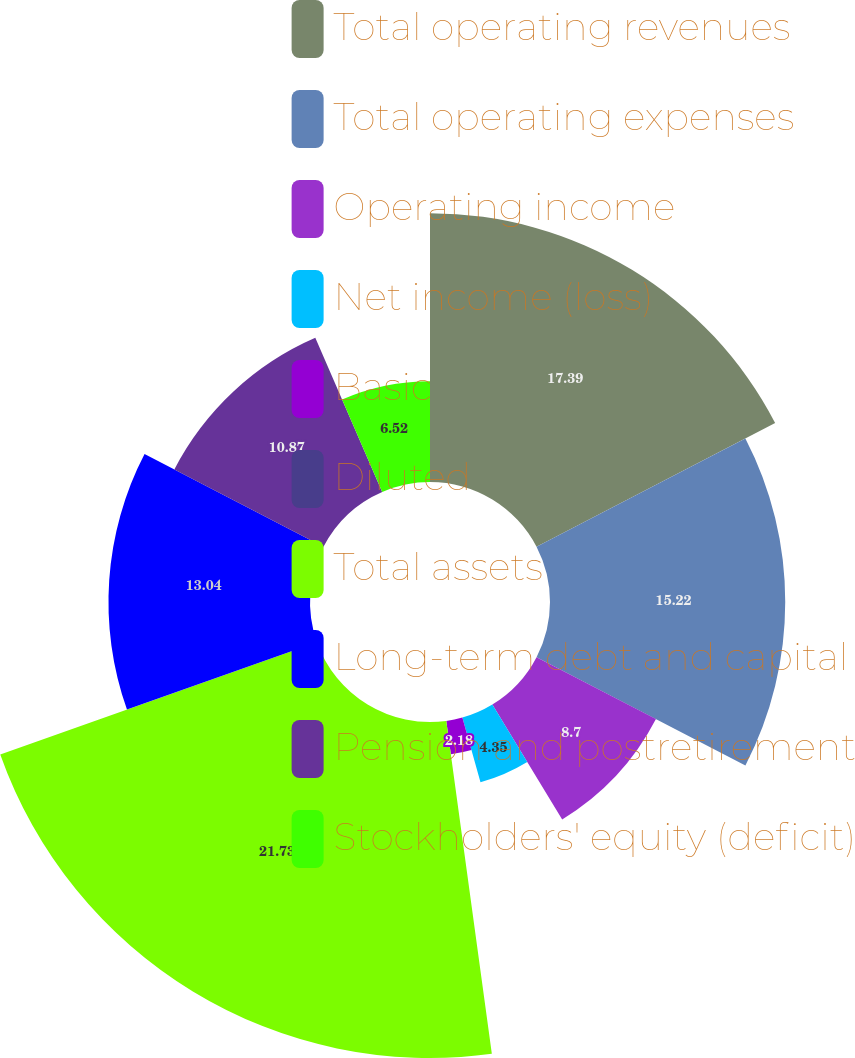Convert chart to OTSL. <chart><loc_0><loc_0><loc_500><loc_500><pie_chart><fcel>Total operating revenues<fcel>Total operating expenses<fcel>Operating income<fcel>Net income (loss)<fcel>Basic<fcel>Diluted<fcel>Total assets<fcel>Long-term debt and capital<fcel>Pension and postretirement<fcel>Stockholders' equity (deficit)<nl><fcel>17.39%<fcel>15.22%<fcel>8.7%<fcel>4.35%<fcel>2.18%<fcel>0.0%<fcel>21.74%<fcel>13.04%<fcel>10.87%<fcel>6.52%<nl></chart> 